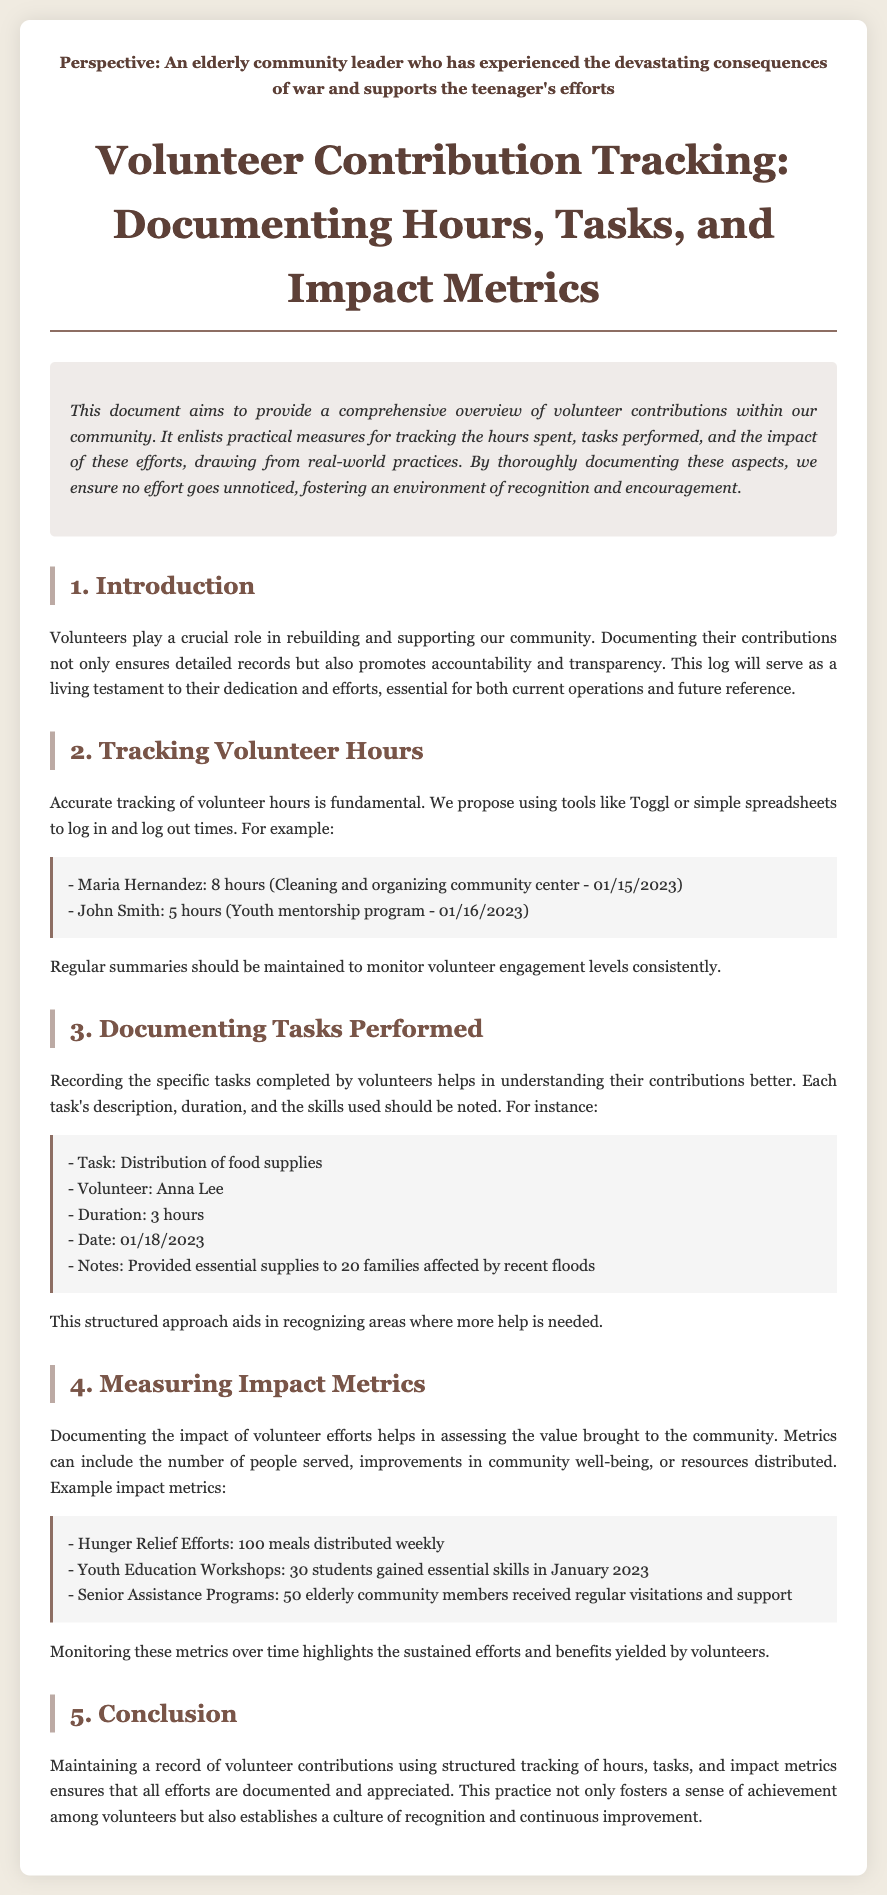what is the title of the document? The title of the document appears at the top of the rendered content, describing its purpose.
Answer: Volunteer Contribution Tracking: Documenting Hours, Tasks, and Impact Metrics who logged 8 hours on January 15, 2023? This information is found in the "Tracking Volunteer Hours" section, where specific volunteer hours are documented.
Answer: Maria Hernandez how many students gained essential skills in January 2023? This number can be found in the "Measuring Impact Metrics" section, which outlines the outcomes of volunteer efforts specifically related to youth education.
Answer: 30 students what task did Anna Lee perform? The task performed is listed under the "Documenting Tasks Performed" section, with details pertaining to her contribution.
Answer: Distribution of food supplies what is one of the impact metrics for hunger relief efforts? This metric is outlined in the "Measuring Impact Metrics" section, summarizing the effectiveness of various volunteer activities.
Answer: 100 meals distributed weekly what is a suggested tool for tracking volunteer hours? The document mentions tools that can be employed for the accurate tracking of volunteer hours in the "Tracking Volunteer Hours" section.
Answer: Toggl 